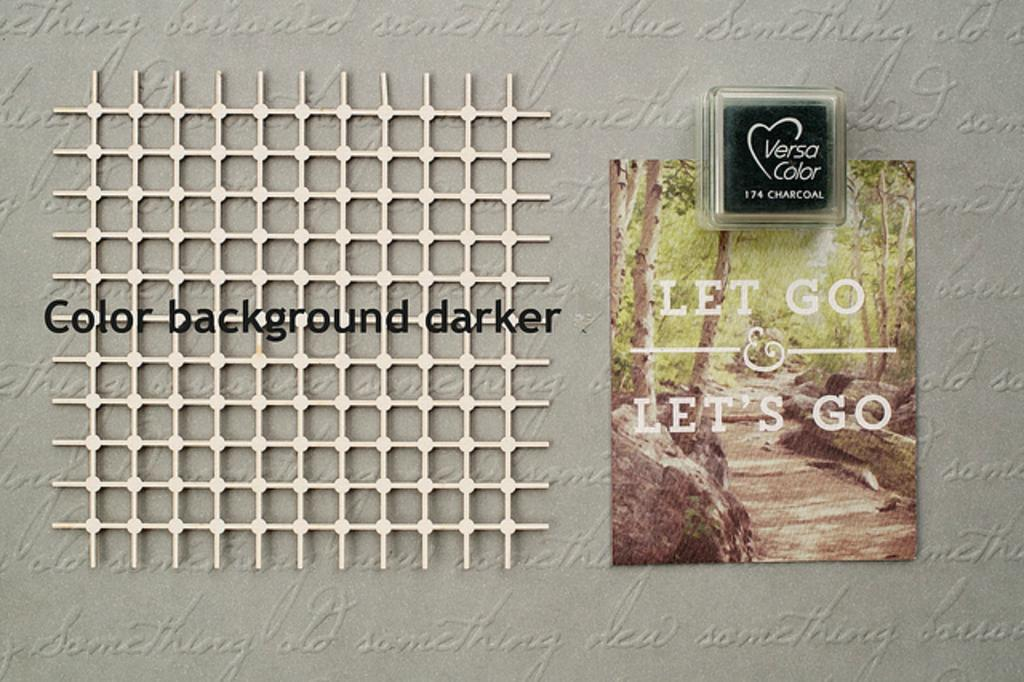What is present on the wall in the image? There is a mesh on the wall in the image. What can be seen in the background of the image? There are trees visible in the image. What is written or displayed in the image? There is some text visible in the image. What type of nut is being used to hold the mesh on the wall in the image? There is no nut present in the image; the mesh is attached to the wall without any visible fasteners. What role does the governor play in the image? There is no governor present in the image, and therefore no role for a governor to play. 